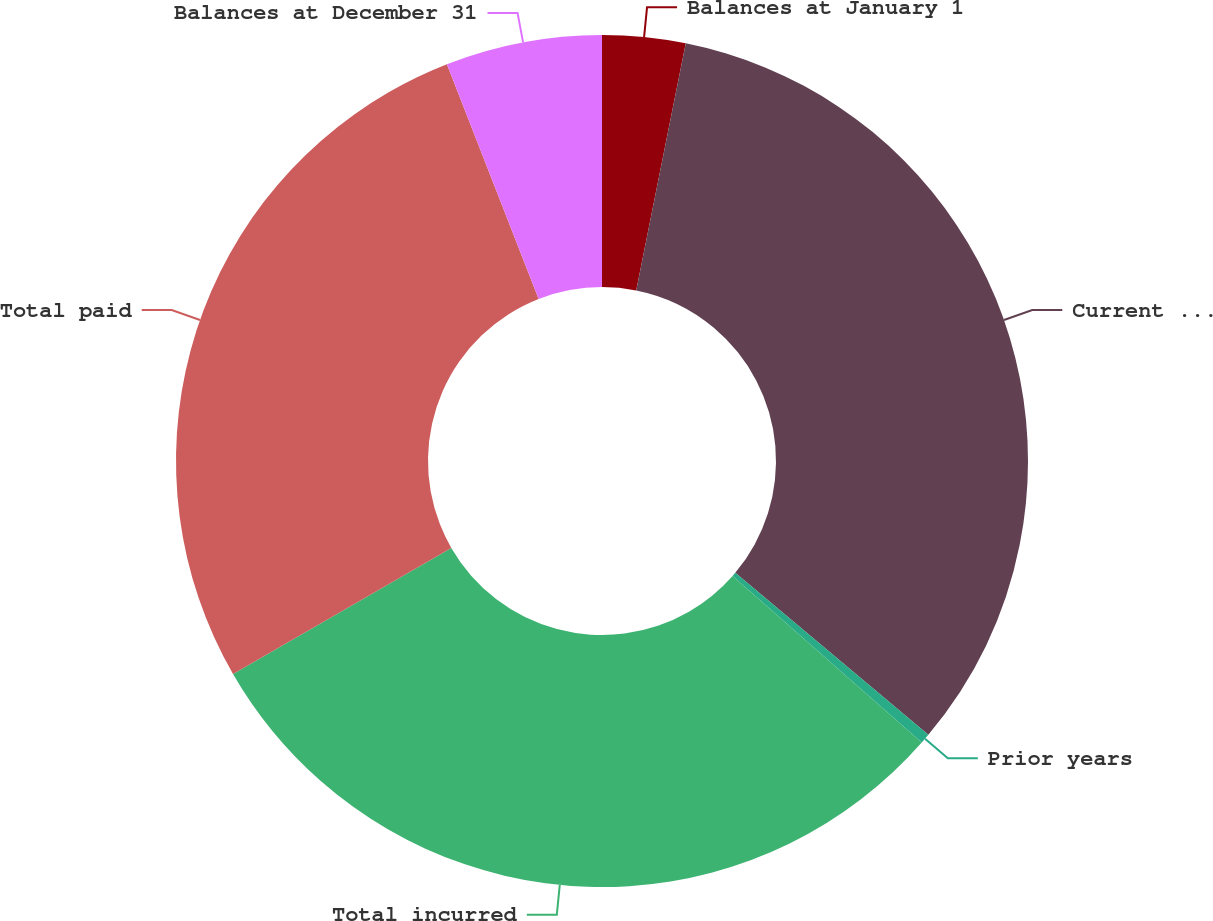<chart> <loc_0><loc_0><loc_500><loc_500><pie_chart><fcel>Balances at January 1<fcel>Current year<fcel>Prior years<fcel>Total incurred<fcel>Total paid<fcel>Balances at December 31<nl><fcel>3.15%<fcel>32.96%<fcel>0.38%<fcel>30.18%<fcel>27.4%<fcel>5.93%<nl></chart> 